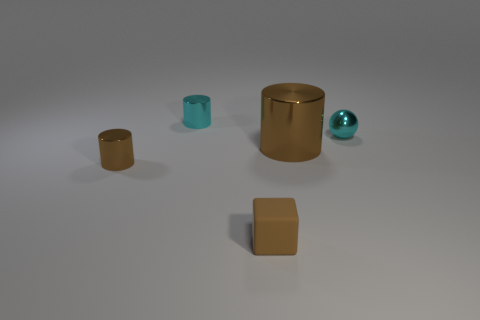The matte object that is the same size as the ball is what color?
Your answer should be compact. Brown. How many blocks are tiny rubber things or small cyan objects?
Your answer should be very brief. 1. There is a tiny rubber thing; is it the same shape as the small cyan object left of the brown rubber thing?
Your response must be concise. No. What number of shiny cylinders are the same size as the brown block?
Offer a terse response. 2. Do the big thing that is on the right side of the small rubber thing and the tiny thing that is on the right side of the brown rubber thing have the same shape?
Your response must be concise. No. There is a big metal thing that is the same color as the tiny rubber block; what is its shape?
Your answer should be very brief. Cylinder. What is the color of the cylinder behind the tiny cyan shiny object that is right of the cyan shiny cylinder?
Provide a succinct answer. Cyan. What is the color of the other small metallic thing that is the same shape as the small brown shiny object?
Offer a very short reply. Cyan. Are there any other things that have the same material as the ball?
Make the answer very short. Yes. What is the size of the cyan metallic object that is the same shape as the large brown metallic object?
Provide a succinct answer. Small. 